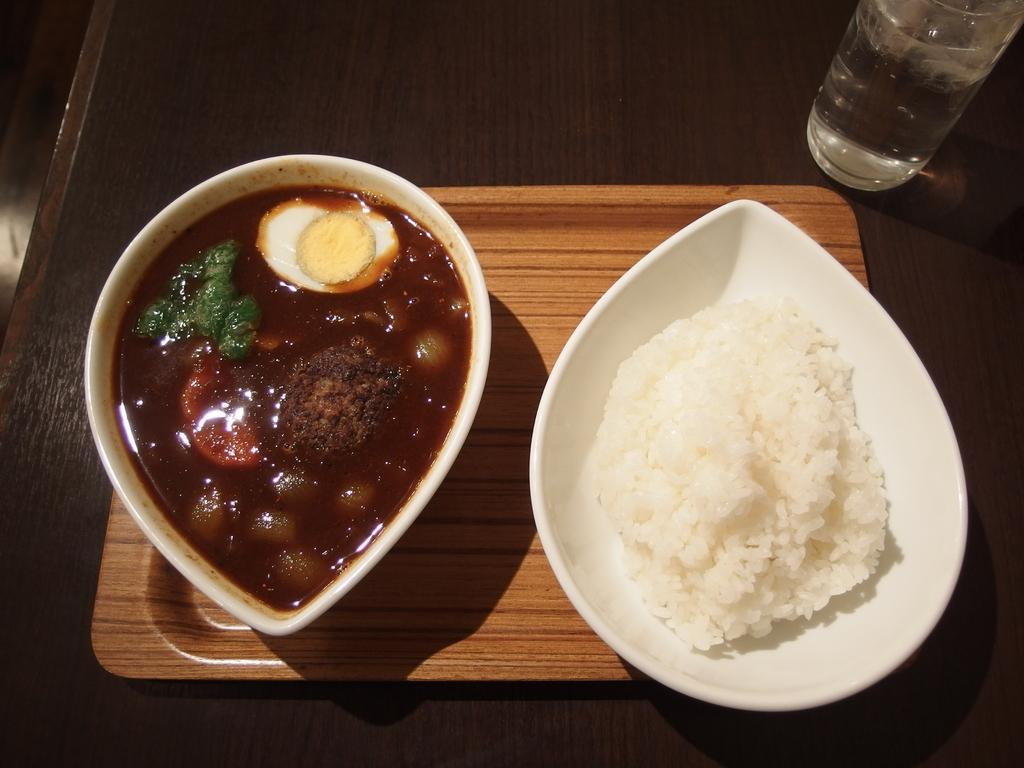What type of food items can be seen in the image? There are food items in bowls in the image. What type of container is present for holding a beverage? There is a glass in the image. What type of dish is present for holding solid food? There is a plate in the image. On what surface are the food items, glass, and plate placed? There is a table in the image. What type of apparel is being worn by the food items in the image? There are no food items wearing apparel in the image, as food items do not wear clothing. 